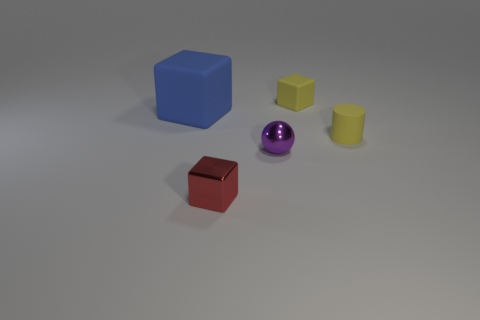Subtract all rubber blocks. How many blocks are left? 1 Subtract all blue blocks. How many blocks are left? 2 Subtract all cylinders. How many objects are left? 4 Subtract 1 balls. How many balls are left? 0 Add 5 tiny metal things. How many objects exist? 10 Add 1 yellow objects. How many yellow objects are left? 3 Add 5 small blue rubber cylinders. How many small blue rubber cylinders exist? 5 Subtract 0 gray blocks. How many objects are left? 5 Subtract all brown cylinders. Subtract all red balls. How many cylinders are left? 1 Subtract all red shiny things. Subtract all green matte cylinders. How many objects are left? 4 